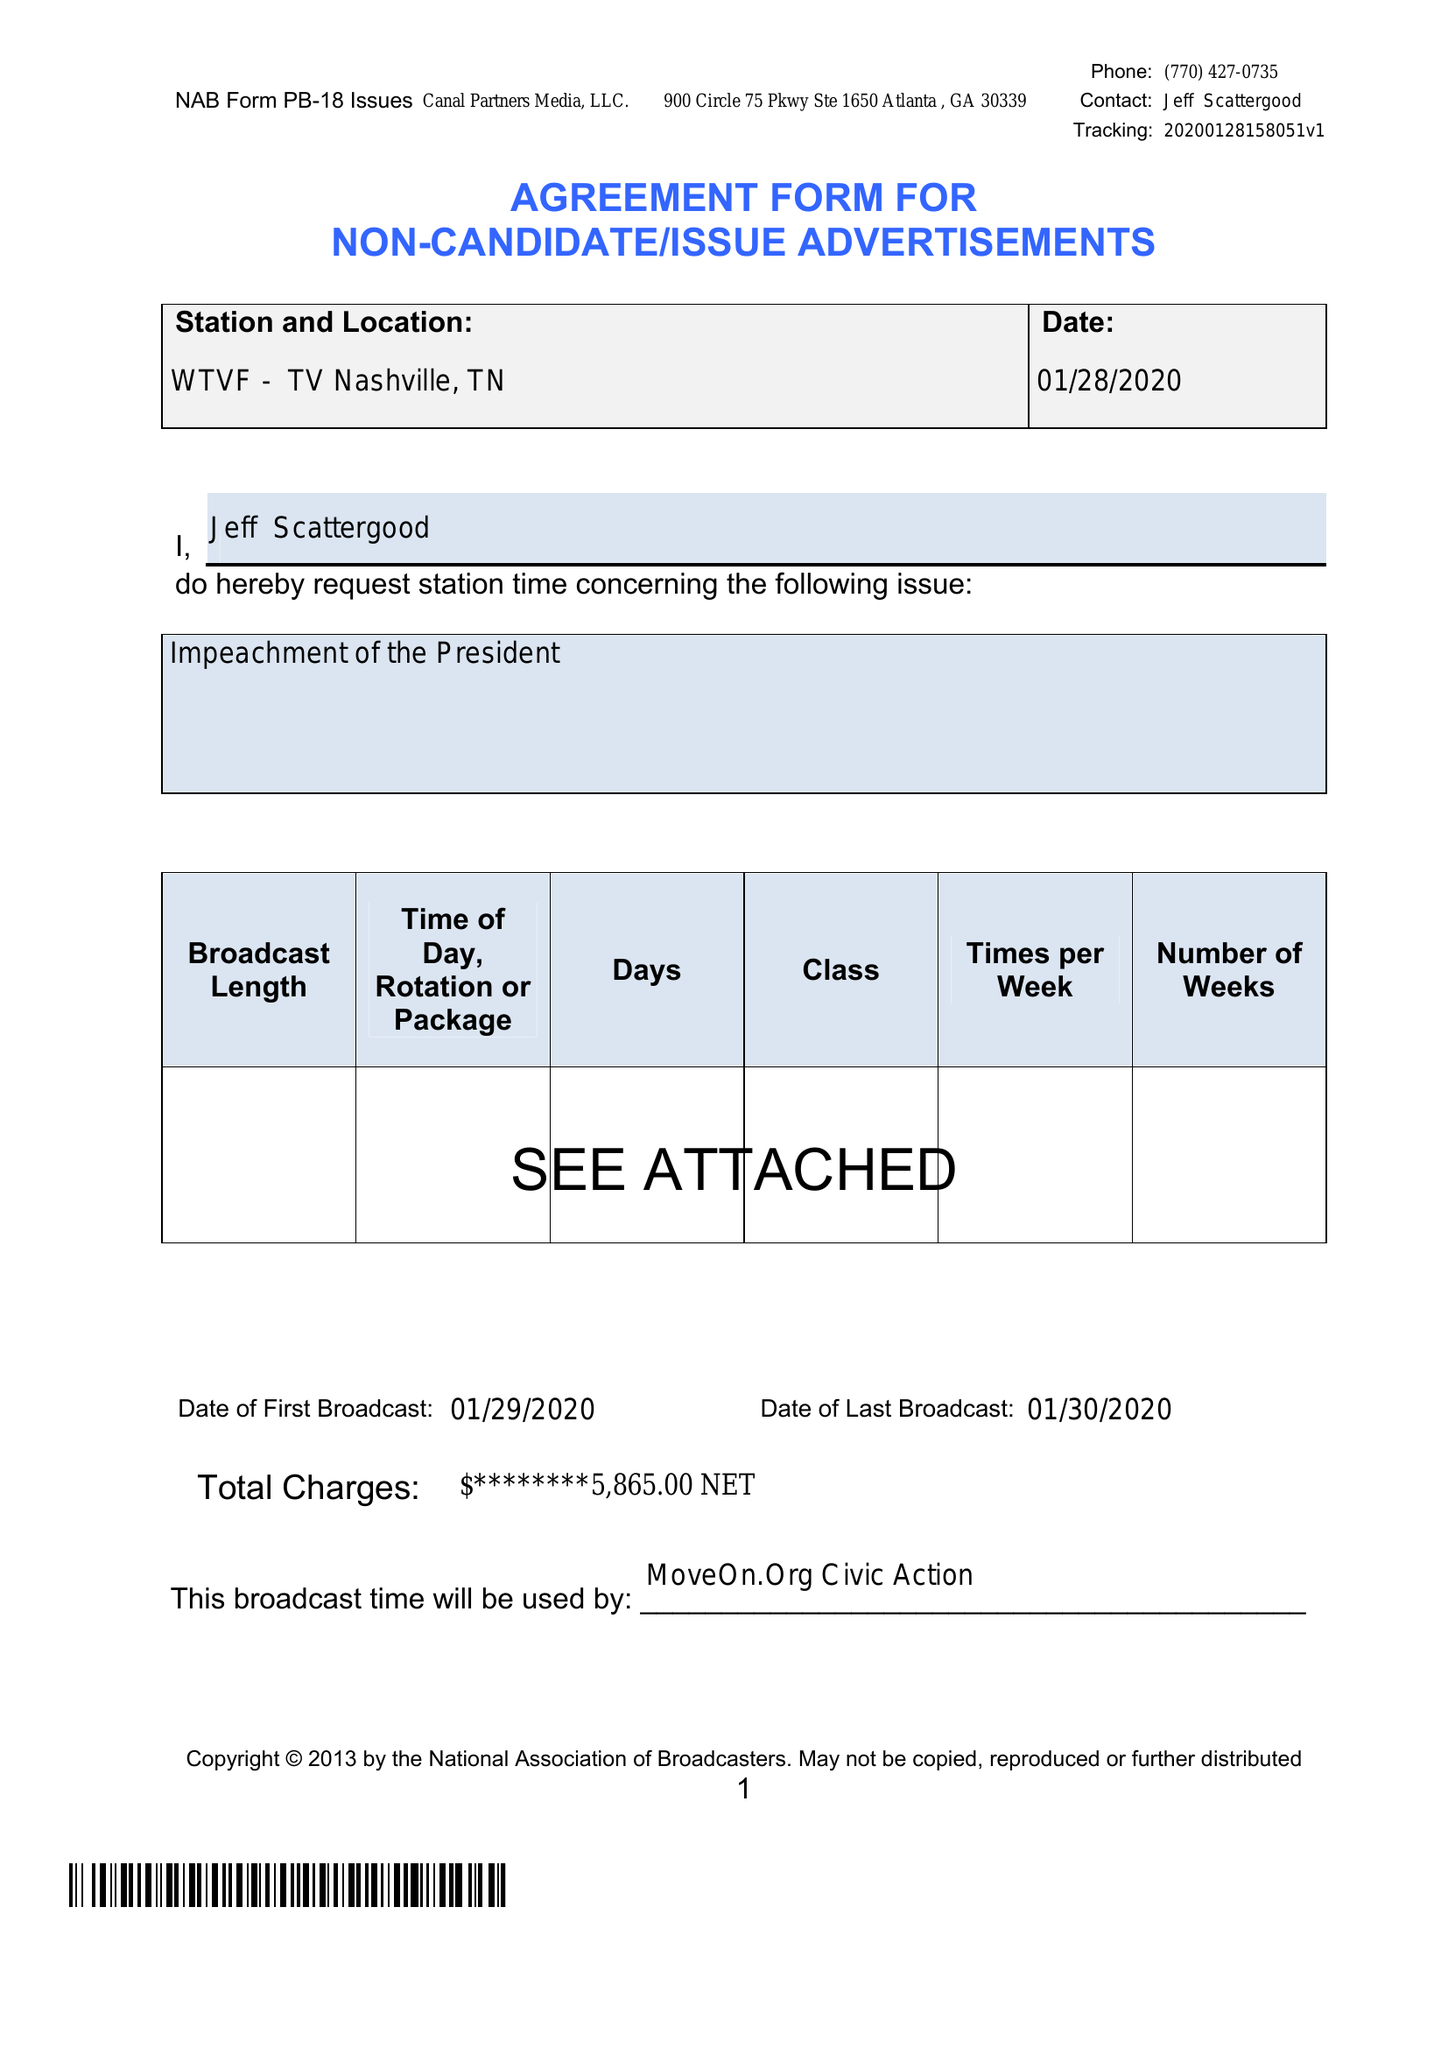What is the value for the flight_from?
Answer the question using a single word or phrase. 01/29/20 